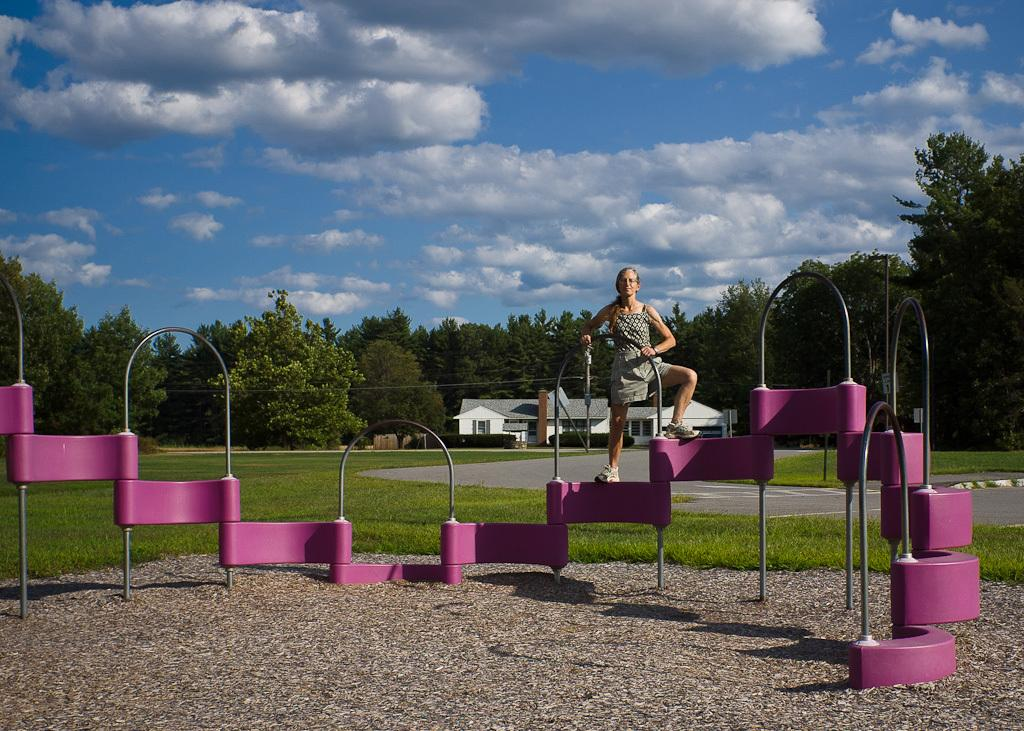What is the woman standing on in the image? The woman is standing on a metal object in the image. What type of surface is beneath the woman? There is grass on the floor beneath the woman. What can be seen in the background of the image? There is a building and trees in the background of the image. How would you describe the weather based on the image? The sky is clear in the image, suggesting good weather. How does the woman increase the property value in the image? There is no indication in the image that the woman is increasing property value. --- Facts: 1. There is a person holding a book. 2. The book has a blue cover. 3. The person is sitting on a chair. 4. There is a table in front of the person. 5. There is a lamp on the table. Absurd Topics: dance, ocean, parrot Conversation: What is the person holding in the image? The person is holding a book in the image. What color is the book's cover? The book has a blue cover. What is the person sitting on in the image? The person is sitting on a chair in the image. What object is in front of the person? There is a table in front of the person. What can be seen on the table? There is a lamp on the table. Reasoning: Let's think step by step in order to produce the conversation. We start by identifying the main subject in the image, which is the person holding a book. Then, we expand the conversation to include details about the book, the person's seating, and the objects on the table. Each question is designed to elicit a specific detail about the image that is known from the provided facts. Absurd Question/Answer: Can you see any parrots flying over the ocean in the image? There is no ocean or parrots present in the image. 